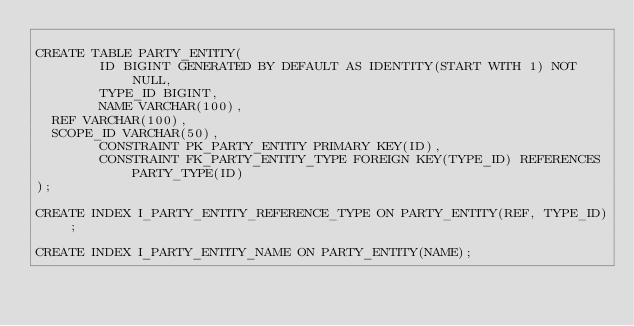Convert code to text. <code><loc_0><loc_0><loc_500><loc_500><_SQL_>
CREATE TABLE PARTY_ENTITY(
        ID BIGINT GENERATED BY DEFAULT AS IDENTITY(START WITH 1) NOT NULL,
        TYPE_ID BIGINT,
        NAME VARCHAR(100),
	REF VARCHAR(100),
	SCOPE_ID VARCHAR(50),
        CONSTRAINT PK_PARTY_ENTITY PRIMARY KEY(ID),
        CONSTRAINT FK_PARTY_ENTITY_TYPE FOREIGN KEY(TYPE_ID) REFERENCES PARTY_TYPE(ID)
);

CREATE INDEX I_PARTY_ENTITY_REFERENCE_TYPE ON PARTY_ENTITY(REF, TYPE_ID);

CREATE INDEX I_PARTY_ENTITY_NAME ON PARTY_ENTITY(NAME);
</code> 